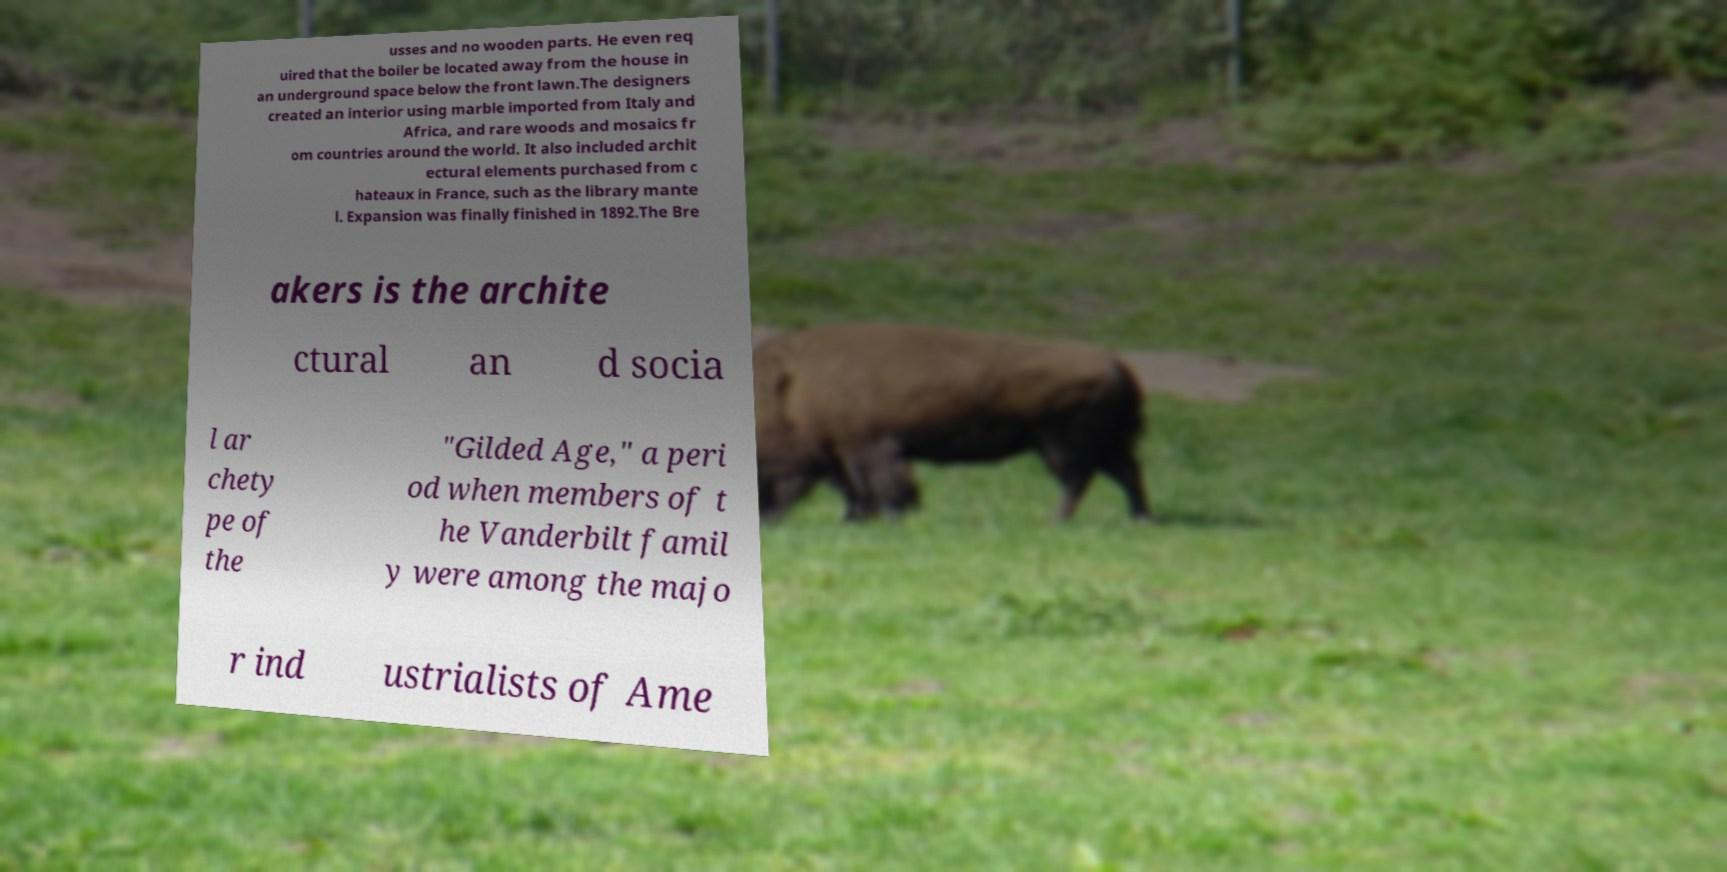Can you read and provide the text displayed in the image?This photo seems to have some interesting text. Can you extract and type it out for me? usses and no wooden parts. He even req uired that the boiler be located away from the house in an underground space below the front lawn.The designers created an interior using marble imported from Italy and Africa, and rare woods and mosaics fr om countries around the world. It also included archit ectural elements purchased from c hateaux in France, such as the library mante l. Expansion was finally finished in 1892.The Bre akers is the archite ctural an d socia l ar chety pe of the "Gilded Age," a peri od when members of t he Vanderbilt famil y were among the majo r ind ustrialists of Ame 